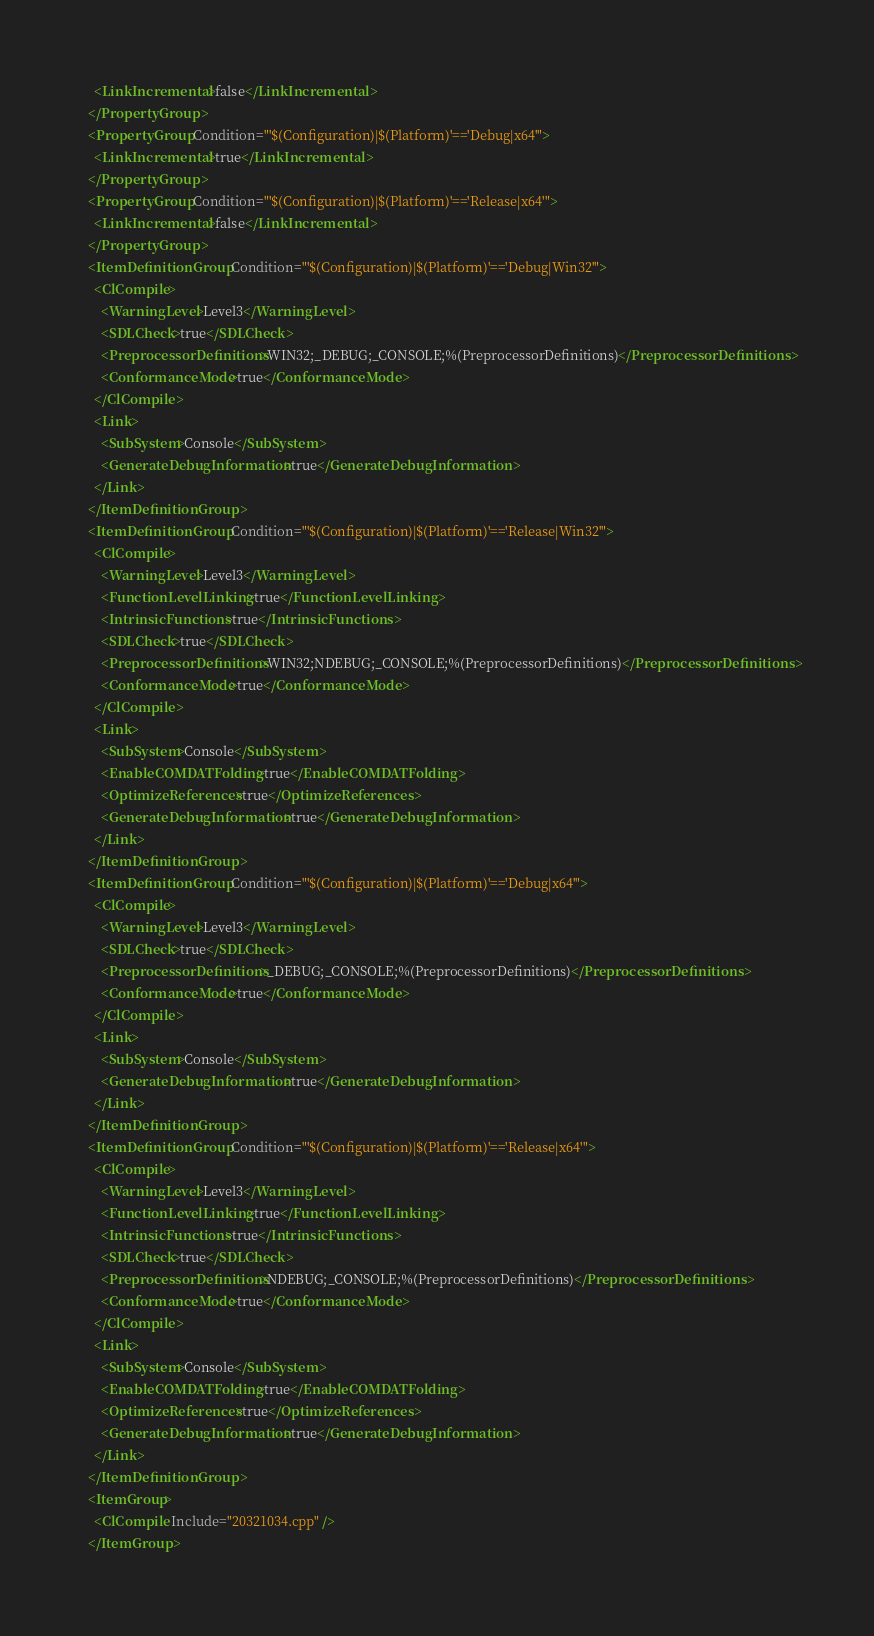Convert code to text. <code><loc_0><loc_0><loc_500><loc_500><_XML_>    <LinkIncremental>false</LinkIncremental>
  </PropertyGroup>
  <PropertyGroup Condition="'$(Configuration)|$(Platform)'=='Debug|x64'">
    <LinkIncremental>true</LinkIncremental>
  </PropertyGroup>
  <PropertyGroup Condition="'$(Configuration)|$(Platform)'=='Release|x64'">
    <LinkIncremental>false</LinkIncremental>
  </PropertyGroup>
  <ItemDefinitionGroup Condition="'$(Configuration)|$(Platform)'=='Debug|Win32'">
    <ClCompile>
      <WarningLevel>Level3</WarningLevel>
      <SDLCheck>true</SDLCheck>
      <PreprocessorDefinitions>WIN32;_DEBUG;_CONSOLE;%(PreprocessorDefinitions)</PreprocessorDefinitions>
      <ConformanceMode>true</ConformanceMode>
    </ClCompile>
    <Link>
      <SubSystem>Console</SubSystem>
      <GenerateDebugInformation>true</GenerateDebugInformation>
    </Link>
  </ItemDefinitionGroup>
  <ItemDefinitionGroup Condition="'$(Configuration)|$(Platform)'=='Release|Win32'">
    <ClCompile>
      <WarningLevel>Level3</WarningLevel>
      <FunctionLevelLinking>true</FunctionLevelLinking>
      <IntrinsicFunctions>true</IntrinsicFunctions>
      <SDLCheck>true</SDLCheck>
      <PreprocessorDefinitions>WIN32;NDEBUG;_CONSOLE;%(PreprocessorDefinitions)</PreprocessorDefinitions>
      <ConformanceMode>true</ConformanceMode>
    </ClCompile>
    <Link>
      <SubSystem>Console</SubSystem>
      <EnableCOMDATFolding>true</EnableCOMDATFolding>
      <OptimizeReferences>true</OptimizeReferences>
      <GenerateDebugInformation>true</GenerateDebugInformation>
    </Link>
  </ItemDefinitionGroup>
  <ItemDefinitionGroup Condition="'$(Configuration)|$(Platform)'=='Debug|x64'">
    <ClCompile>
      <WarningLevel>Level3</WarningLevel>
      <SDLCheck>true</SDLCheck>
      <PreprocessorDefinitions>_DEBUG;_CONSOLE;%(PreprocessorDefinitions)</PreprocessorDefinitions>
      <ConformanceMode>true</ConformanceMode>
    </ClCompile>
    <Link>
      <SubSystem>Console</SubSystem>
      <GenerateDebugInformation>true</GenerateDebugInformation>
    </Link>
  </ItemDefinitionGroup>
  <ItemDefinitionGroup Condition="'$(Configuration)|$(Platform)'=='Release|x64'">
    <ClCompile>
      <WarningLevel>Level3</WarningLevel>
      <FunctionLevelLinking>true</FunctionLevelLinking>
      <IntrinsicFunctions>true</IntrinsicFunctions>
      <SDLCheck>true</SDLCheck>
      <PreprocessorDefinitions>NDEBUG;_CONSOLE;%(PreprocessorDefinitions)</PreprocessorDefinitions>
      <ConformanceMode>true</ConformanceMode>
    </ClCompile>
    <Link>
      <SubSystem>Console</SubSystem>
      <EnableCOMDATFolding>true</EnableCOMDATFolding>
      <OptimizeReferences>true</OptimizeReferences>
      <GenerateDebugInformation>true</GenerateDebugInformation>
    </Link>
  </ItemDefinitionGroup>
  <ItemGroup>
    <ClCompile Include="20321034.cpp" />
  </ItemGroup></code> 